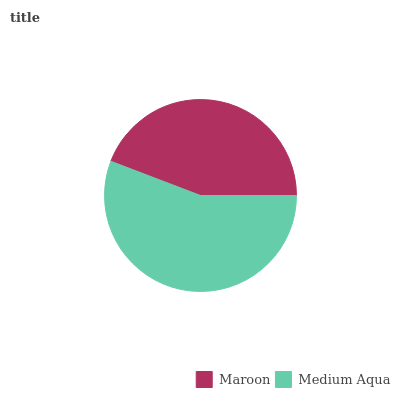Is Maroon the minimum?
Answer yes or no. Yes. Is Medium Aqua the maximum?
Answer yes or no. Yes. Is Medium Aqua the minimum?
Answer yes or no. No. Is Medium Aqua greater than Maroon?
Answer yes or no. Yes. Is Maroon less than Medium Aqua?
Answer yes or no. Yes. Is Maroon greater than Medium Aqua?
Answer yes or no. No. Is Medium Aqua less than Maroon?
Answer yes or no. No. Is Medium Aqua the high median?
Answer yes or no. Yes. Is Maroon the low median?
Answer yes or no. Yes. Is Maroon the high median?
Answer yes or no. No. Is Medium Aqua the low median?
Answer yes or no. No. 